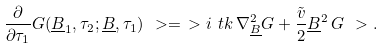Convert formula to latex. <formula><loc_0><loc_0><loc_500><loc_500>\frac { \partial } { \partial \tau _ { 1 } } G ( \underline { B } _ { 1 } , \tau _ { 2 } ; \underline { B } , \tau _ { 1 } ) \ > = \ > i \ t k \, \nabla ^ { 2 } _ { \underline { B } } G + \frac { \tilde { v } } { 2 } \underline { B } ^ { 2 } \, G \ > .</formula> 